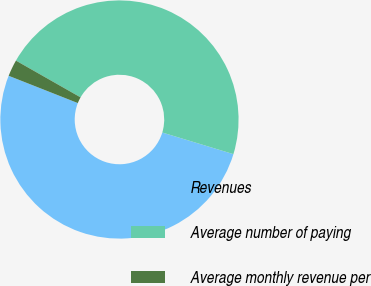Convert chart to OTSL. <chart><loc_0><loc_0><loc_500><loc_500><pie_chart><fcel>Revenues<fcel>Average number of paying<fcel>Average monthly revenue per<nl><fcel>51.28%<fcel>46.46%<fcel>2.25%<nl></chart> 